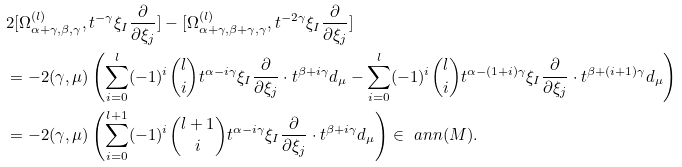Convert formula to latex. <formula><loc_0><loc_0><loc_500><loc_500>& 2 [ \Omega _ { \alpha + \gamma , \beta , \gamma } ^ { ( l ) } , t ^ { - \gamma } \xi _ { I } \frac { \partial } { \partial \xi _ { j } } ] - [ \Omega _ { \alpha + \gamma , \beta + \gamma , \gamma } ^ { ( l ) } , t ^ { - 2 \gamma } \xi _ { I } \frac { \partial } { \partial \xi _ { j } } ] \\ & = - 2 ( \gamma , \mu ) \left ( \sum _ { i = 0 } ^ { l } ( - 1 ) ^ { i } \binom { l } i t ^ { \alpha - i \gamma } \xi _ { I } \frac { \partial } { \partial \xi _ { j } } \cdot t ^ { \beta + i \gamma } d _ { \mu } - \sum _ { i = 0 } ^ { l } ( - 1 ) ^ { i } \binom { l } i t ^ { \alpha - ( 1 + i ) \gamma } \xi _ { I } \frac { \partial } { \partial \xi _ { j } } \cdot t ^ { \beta + ( i + 1 ) \gamma } d _ { \mu } \right ) \\ & = - 2 ( \gamma , \mu ) \left ( \sum _ { i = 0 } ^ { l + 1 } ( - 1 ) ^ { i } \binom { l + 1 } i t ^ { \alpha - i \gamma } \xi _ { I } \frac { \partial } { \partial \xi _ { j } } \cdot t ^ { \beta + i \gamma } d _ { \mu } \right ) \in \ a n n ( M ) .</formula> 